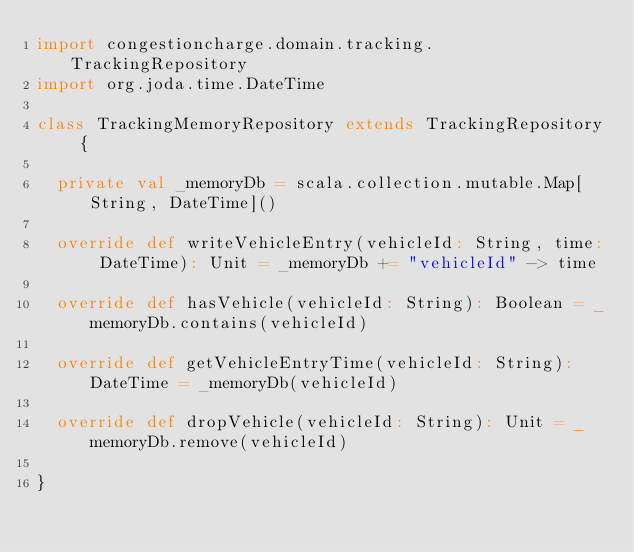Convert code to text. <code><loc_0><loc_0><loc_500><loc_500><_Scala_>import congestioncharge.domain.tracking.TrackingRepository
import org.joda.time.DateTime

class TrackingMemoryRepository extends TrackingRepository {

  private val _memoryDb = scala.collection.mutable.Map[String, DateTime]()

  override def writeVehicleEntry(vehicleId: String, time: DateTime): Unit = _memoryDb += "vehicleId" -> time

  override def hasVehicle(vehicleId: String): Boolean = _memoryDb.contains(vehicleId)

  override def getVehicleEntryTime(vehicleId: String): DateTime = _memoryDb(vehicleId)

  override def dropVehicle(vehicleId: String): Unit = _memoryDb.remove(vehicleId)

}
</code> 